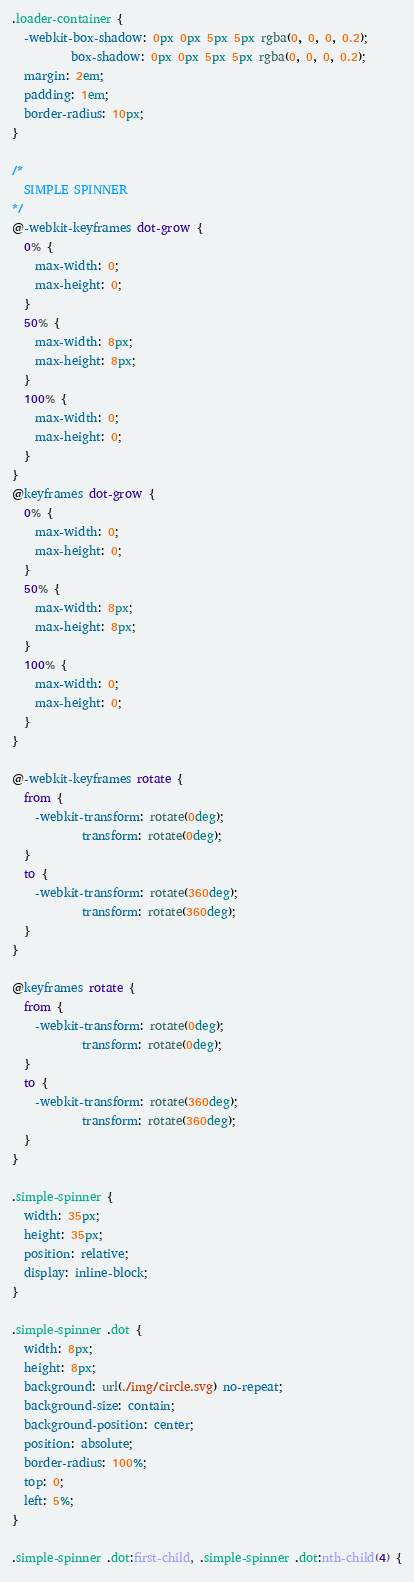<code> <loc_0><loc_0><loc_500><loc_500><_CSS_>.loader-container {
  -webkit-box-shadow: 0px 0px 5px 5px rgba(0, 0, 0, 0.2);
          box-shadow: 0px 0px 5px 5px rgba(0, 0, 0, 0.2);
  margin: 2em;
  padding: 1em;
  border-radius: 10px;
}

/*
  SIMPLE SPINNER
*/
@-webkit-keyframes dot-grow {
  0% {
    max-width: 0;
    max-height: 0;
  }
  50% {
    max-width: 8px;
    max-height: 8px;
  }
  100% {
    max-width: 0;
    max-height: 0;
  }
}
@keyframes dot-grow {
  0% {
    max-width: 0;
    max-height: 0;
  }
  50% {
    max-width: 8px;
    max-height: 8px;
  }
  100% {
    max-width: 0;
    max-height: 0;
  }
}

@-webkit-keyframes rotate {
  from {
    -webkit-transform: rotate(0deg);
            transform: rotate(0deg);
  }
  to {
    -webkit-transform: rotate(360deg);
            transform: rotate(360deg);
  }
}

@keyframes rotate {
  from {
    -webkit-transform: rotate(0deg);
            transform: rotate(0deg);
  }
  to {
    -webkit-transform: rotate(360deg);
            transform: rotate(360deg);
  }
}

.simple-spinner {
  width: 35px;
  height: 35px;
  position: relative;
  display: inline-block;
}

.simple-spinner .dot {
  width: 8px;
  height: 8px;
  background: url(./img/circle.svg) no-repeat;
  background-size: contain;
  background-position: center;
  position: absolute;
  border-radius: 100%;
  top: 0;
  left: 5%;
}

.simple-spinner .dot:first-child, .simple-spinner .dot:nth-child(4) {</code> 